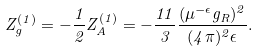<formula> <loc_0><loc_0><loc_500><loc_500>Z _ { g } ^ { ( 1 ) } = - \frac { 1 } { 2 } Z _ { A } ^ { ( 1 ) } = - \frac { 1 1 } 3 \frac { ( \mu ^ { - \epsilon } g _ { R } ) ^ { 2 } } { ( 4 \pi ) ^ { 2 } \epsilon } .</formula> 